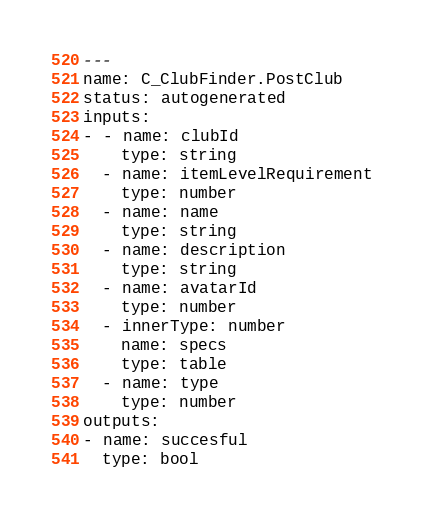<code> <loc_0><loc_0><loc_500><loc_500><_YAML_>---
name: C_ClubFinder.PostClub
status: autogenerated
inputs:
- - name: clubId
    type: string
  - name: itemLevelRequirement
    type: number
  - name: name
    type: string
  - name: description
    type: string
  - name: avatarId
    type: number
  - innerType: number
    name: specs
    type: table
  - name: type
    type: number
outputs:
- name: succesful
  type: bool
</code> 